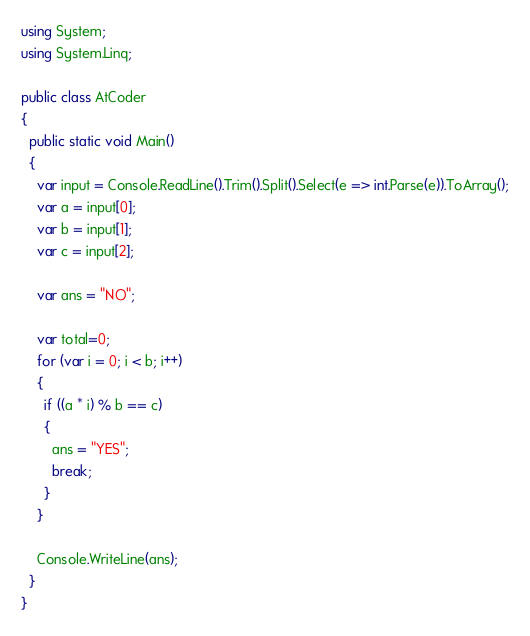<code> <loc_0><loc_0><loc_500><loc_500><_C#_>using System;
using System.Linq;

public class AtCoder
{
  public static void Main()
  {
    var input = Console.ReadLine().Trim().Split().Select(e => int.Parse(e)).ToArray();
    var a = input[0];
    var b = input[1];
    var c = input[2];

    var ans = "NO";

    var total=0;
    for (var i = 0; i < b; i++)
    {
      if ((a * i) % b == c)
      {
        ans = "YES";
        break;
      }
    }

    Console.WriteLine(ans);
  }
}</code> 